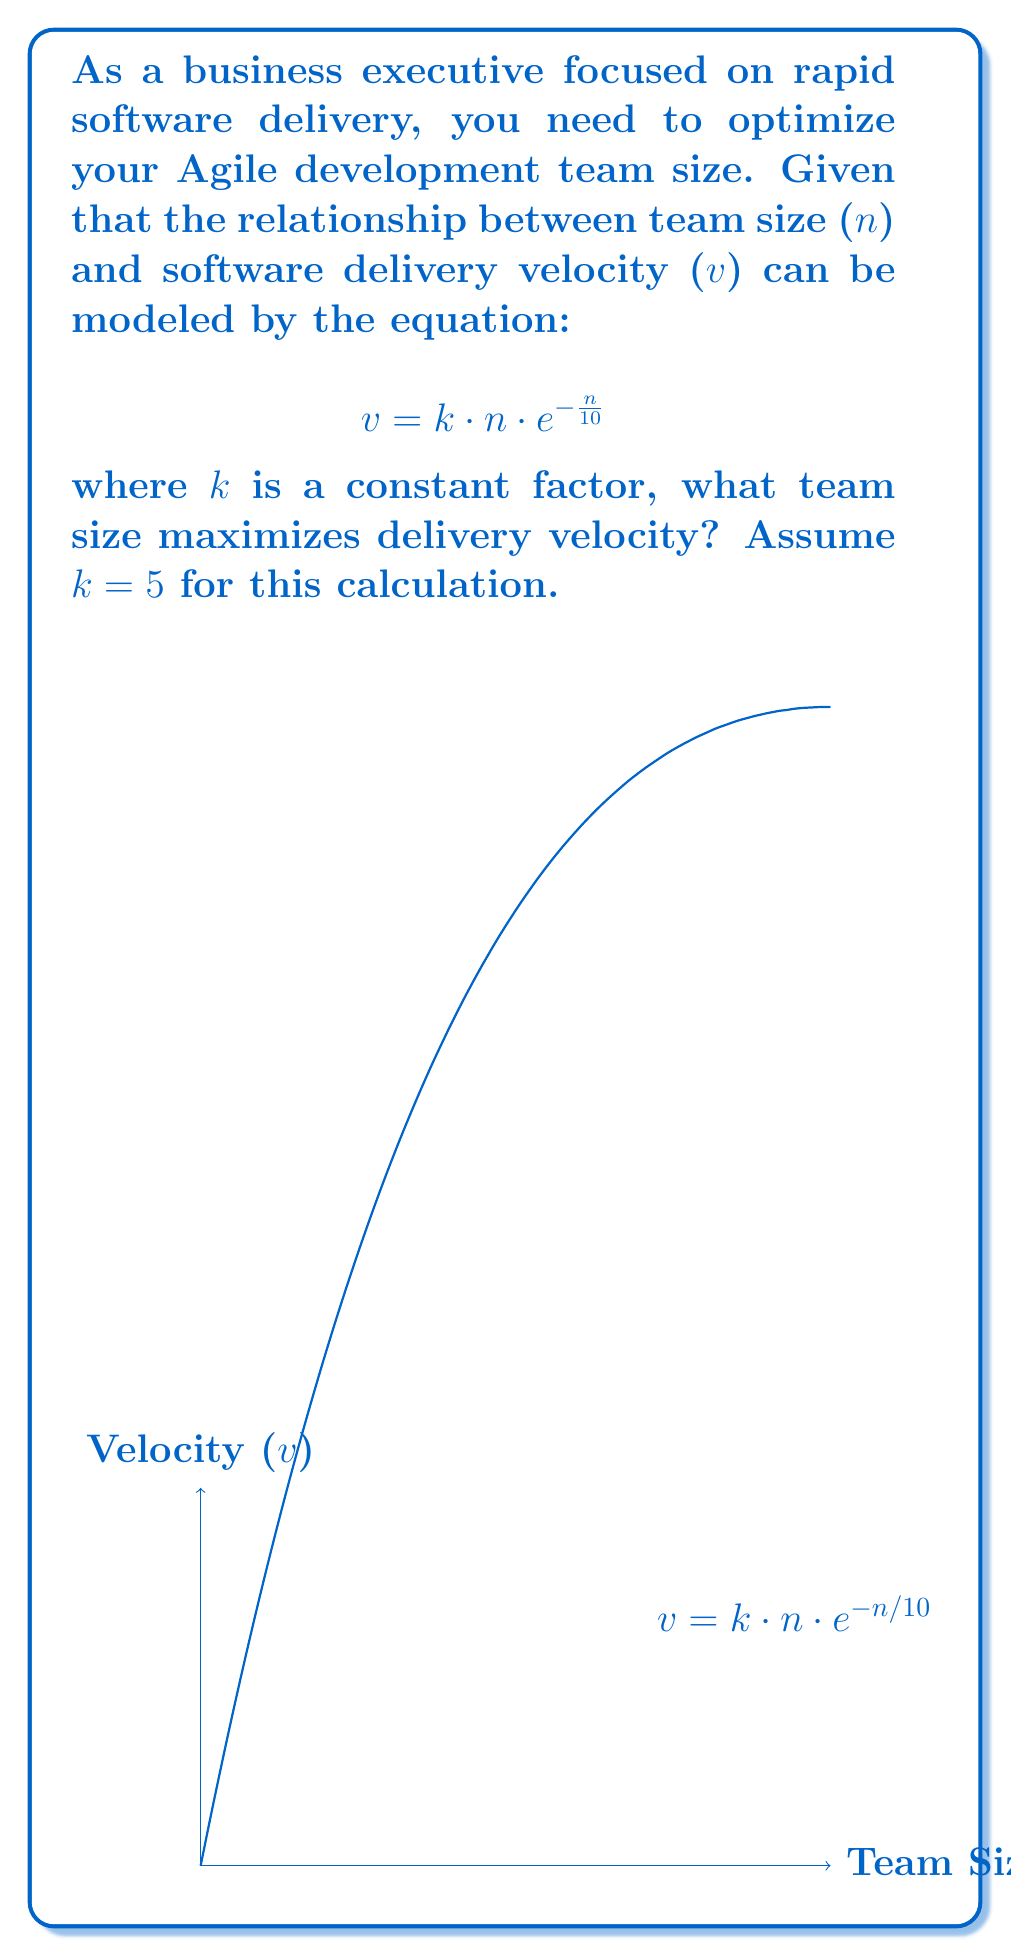What is the answer to this math problem? To find the team size that maximizes delivery velocity, we need to find the maximum of the function:

$$ v = 5n \cdot e^{-\frac{n}{10}} $$

1. Take the derivative of $v$ with respect to $n$:

   $$ \frac{dv}{dn} = 5e^{-\frac{n}{10}} + 5n \cdot e^{-\frac{n}{10}} \cdot (-\frac{1}{10}) $$

2. Simplify:

   $$ \frac{dv}{dn} = 5e^{-\frac{n}{10}} (1 - \frac{n}{10}) $$

3. Set the derivative to zero and solve for $n$:

   $$ 5e^{-\frac{n}{10}} (1 - \frac{n}{10}) = 0 $$

   $$ 1 - \frac{n}{10} = 0 $$
   
   $$ n = 10 $$

4. Verify this is a maximum by checking the second derivative is negative at $n=10$.

Therefore, the team size that maximizes delivery velocity is 10 people.
Answer: 10 people 